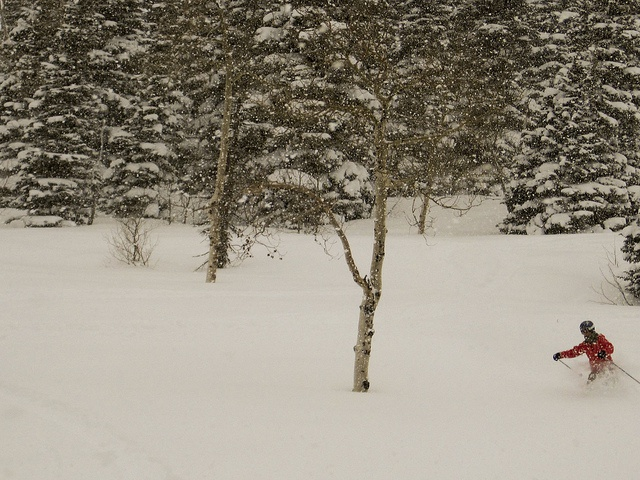Describe the objects in this image and their specific colors. I can see people in darkgray, maroon, black, brown, and gray tones and skis in darkgray tones in this image. 